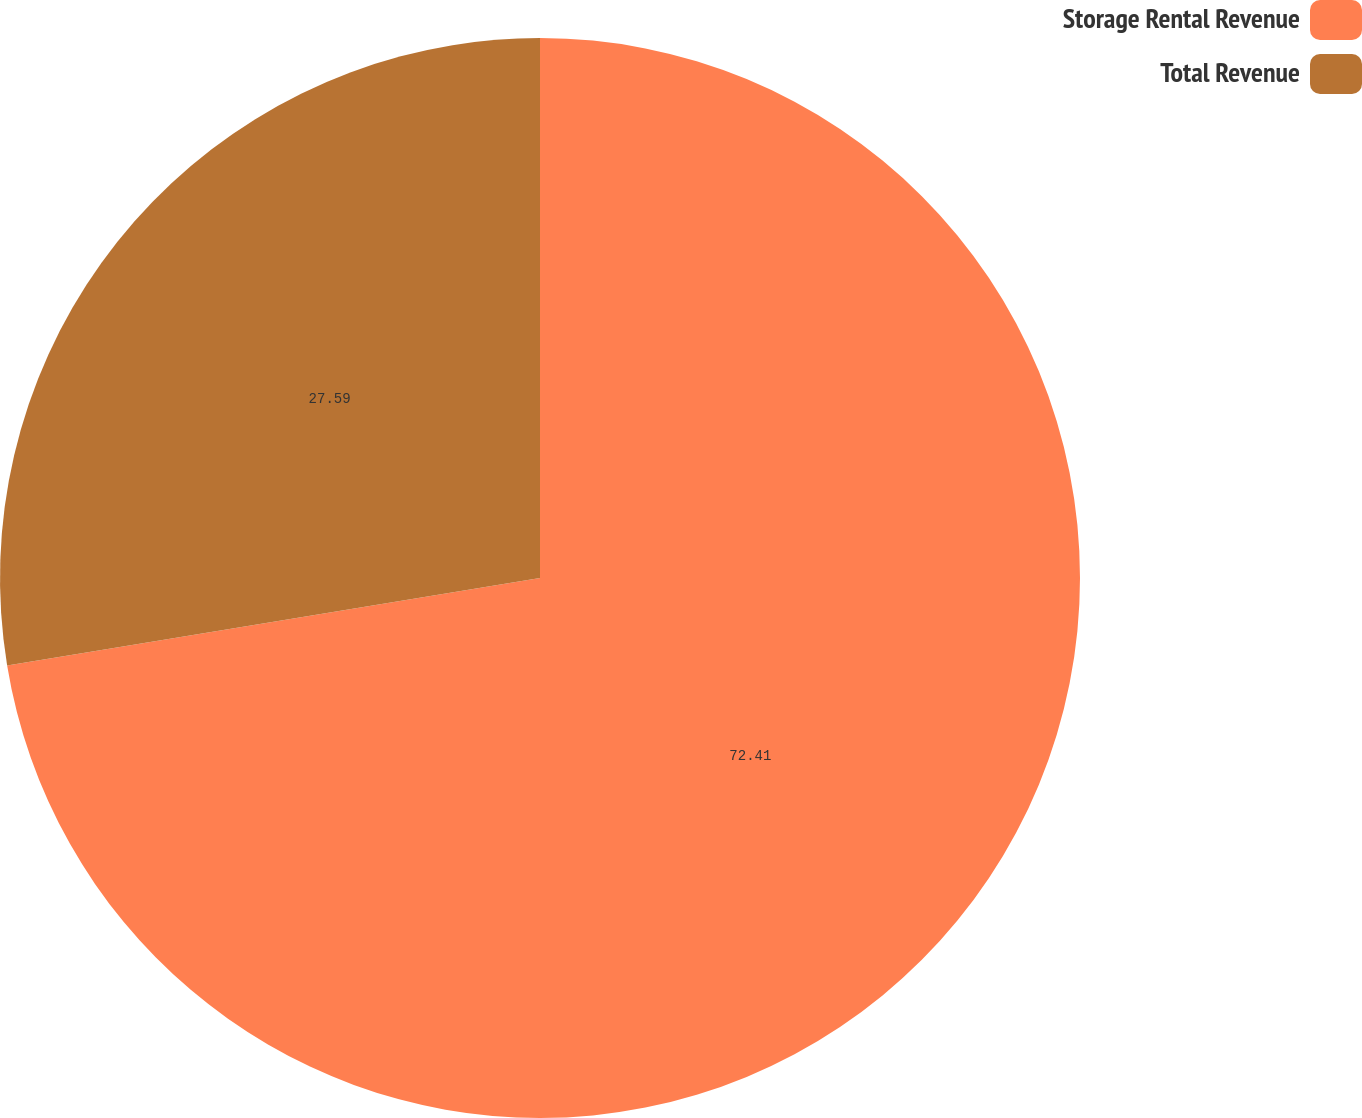Convert chart. <chart><loc_0><loc_0><loc_500><loc_500><pie_chart><fcel>Storage Rental Revenue<fcel>Total Revenue<nl><fcel>72.41%<fcel>27.59%<nl></chart> 